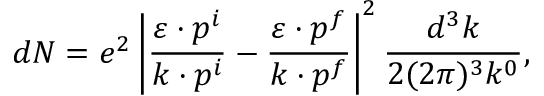<formula> <loc_0><loc_0><loc_500><loc_500>d N = e ^ { 2 } \left | \frac { \varepsilon \cdot p ^ { i } } { k \cdot p ^ { i } } - \frac { \varepsilon \cdot p ^ { f } } { k \cdot p ^ { f } } \right | ^ { 2 } \frac { d ^ { 3 } k } { 2 ( 2 \pi ) ^ { 3 } k ^ { 0 } } ,</formula> 